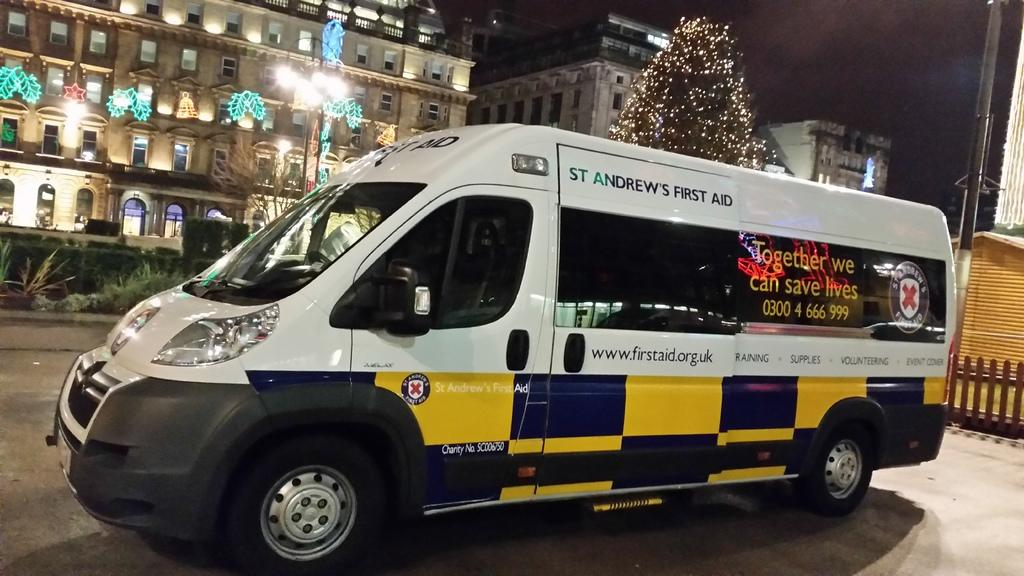<image>
Write a terse but informative summary of the picture. a van that says St Andrews First Aid on it 